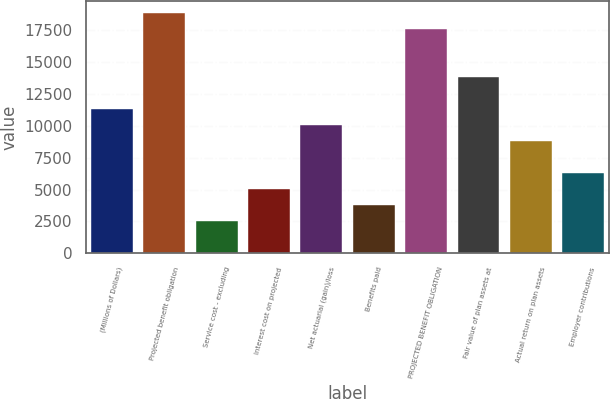<chart> <loc_0><loc_0><loc_500><loc_500><bar_chart><fcel>(Millions of Dollars)<fcel>Projected benefit obligation<fcel>Service cost - excluding<fcel>Interest cost on projected<fcel>Net actuarial (gain)/loss<fcel>Benefits paid<fcel>PROJECTED BENEFIT OBLIGATION<fcel>Fair value of plan assets at<fcel>Actual return on plan assets<fcel>Employer contributions<nl><fcel>11315.4<fcel>18855<fcel>2519.2<fcel>5032.4<fcel>10058.8<fcel>3775.8<fcel>17598.4<fcel>13828.6<fcel>8802.2<fcel>6289<nl></chart> 